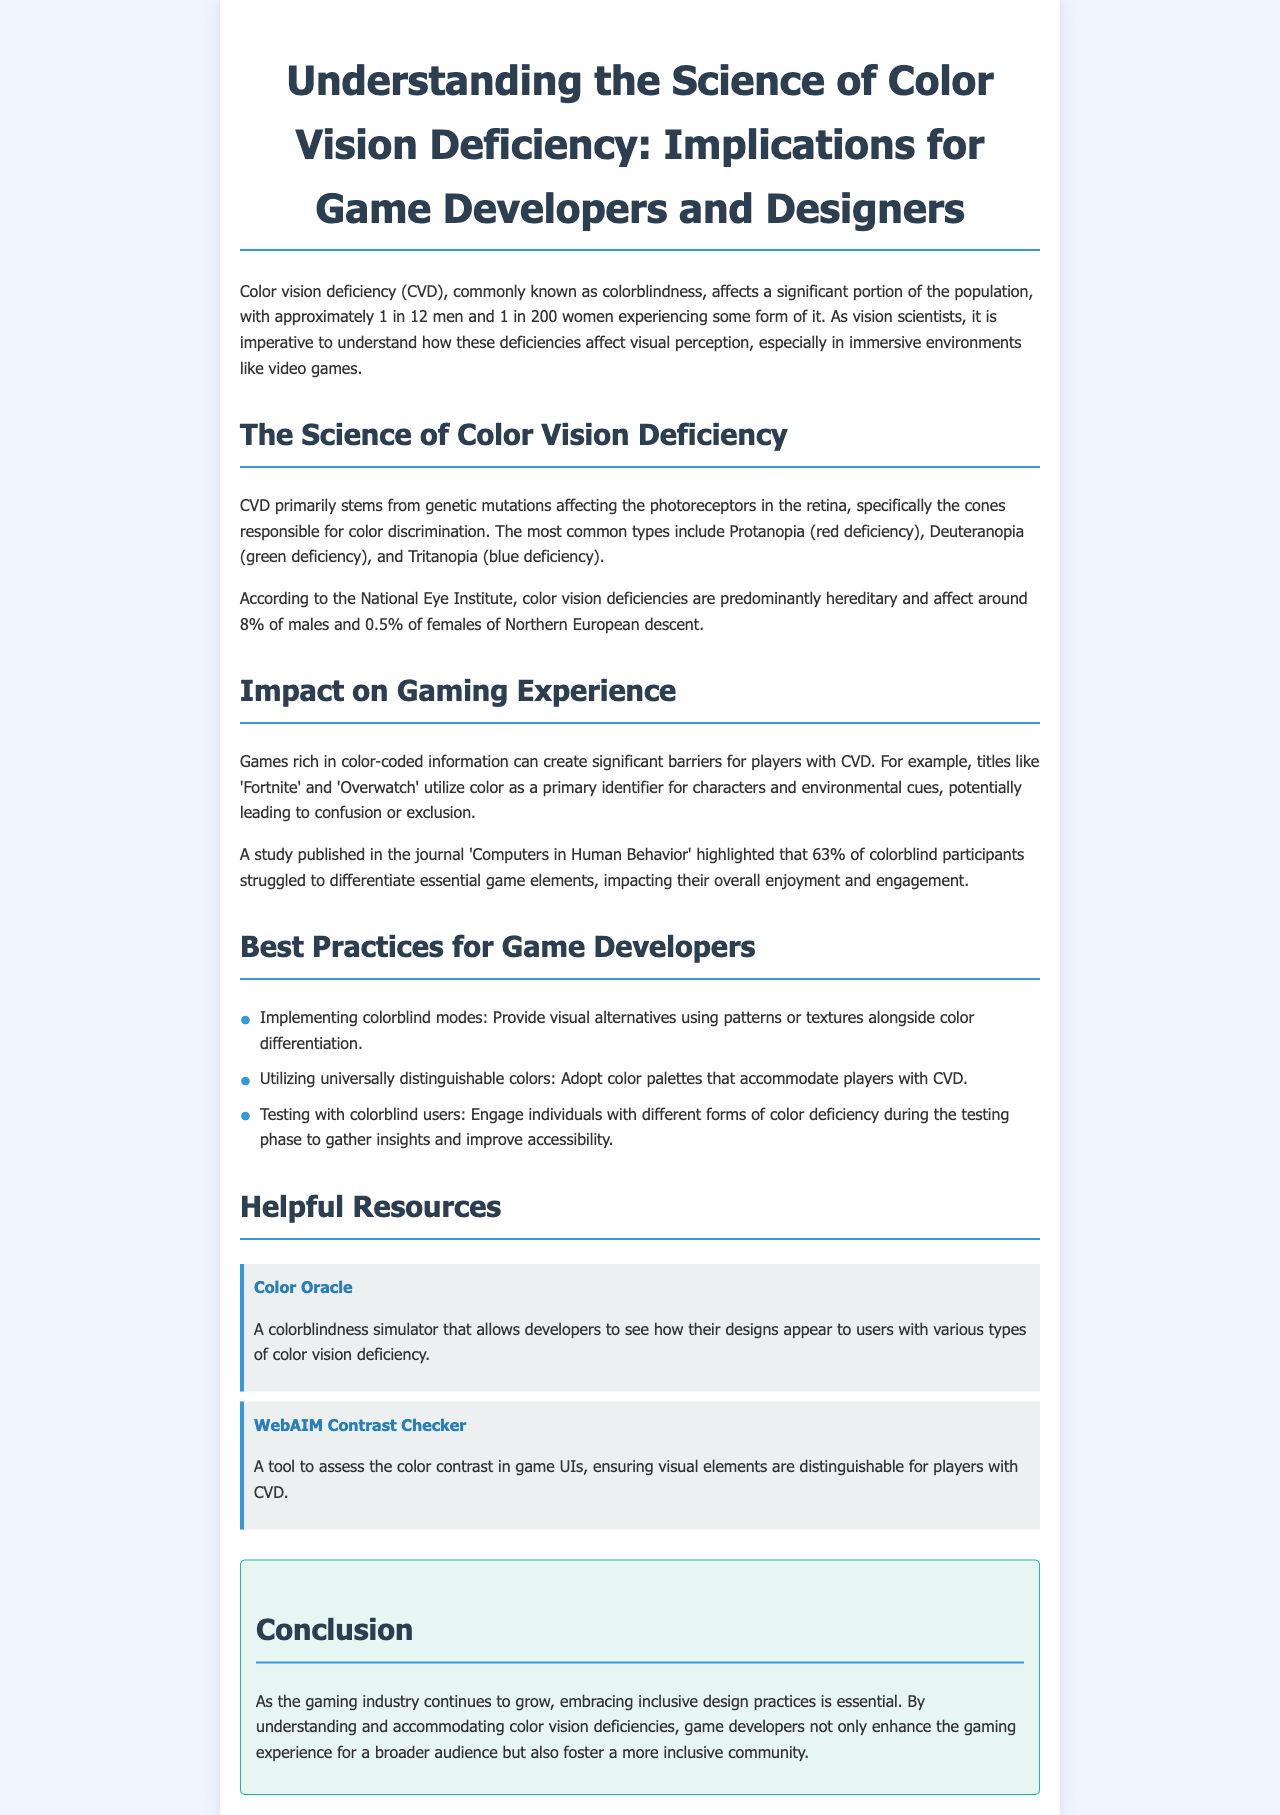What is the prevalence of color vision deficiency in men? The document states that approximately 1 in 12 men experience some form of color vision deficiency.
Answer: 1 in 12 What are the three common types of color vision deficiency? The document lists Protanopia, Deuteranopia, and Tritanopia as the common types.
Answer: Protanopia, Deuteranopia, Tritanopia What percentage of colorblind participants struggled to differentiate game elements according to the study? The document mentions that 63% of colorblind participants had difficulty in differentiating game elements.
Answer: 63% What is one recommended best practice for game developers? The document advises implementing colorblind modes as one of the best practices.
Answer: Implementing colorblind modes What is the purpose of the Color Oracle tool? The Color Oracle is a simulator that allows developers to see designs from the perspective of users with color vision deficiency.
Answer: To simulate color vision deficiency How many women experience color vision deficiency, as mentioned in the document? The document specifies that approximately 1 in 200 women experience color vision deficiency.
Answer: 1 in 200 What is a key takeaway in the conclusion regarding game developers? The conclusion emphasizes the importance of understanding and accommodating color vision deficiencies.
Answer: Enhance the gaming experience What is one visual alternative recommended for players with CVD? The document suggests providing visual alternatives using patterns or textures alongside color differentiation.
Answer: Patterns or textures 